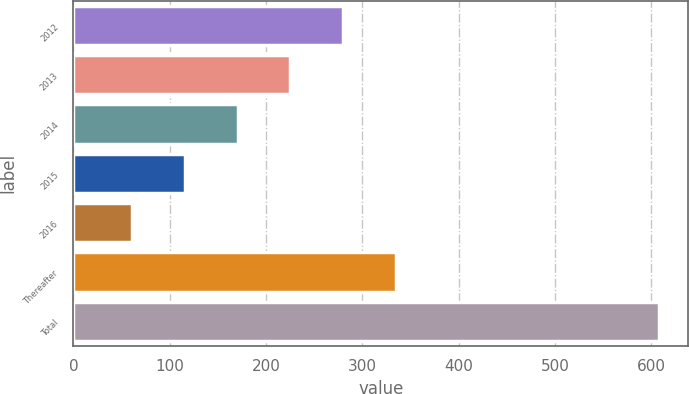Convert chart to OTSL. <chart><loc_0><loc_0><loc_500><loc_500><bar_chart><fcel>2012<fcel>2013<fcel>2014<fcel>2015<fcel>2016<fcel>Thereafter<fcel>Total<nl><fcel>279.8<fcel>225.1<fcel>170.4<fcel>115.7<fcel>61<fcel>334.5<fcel>608<nl></chart> 